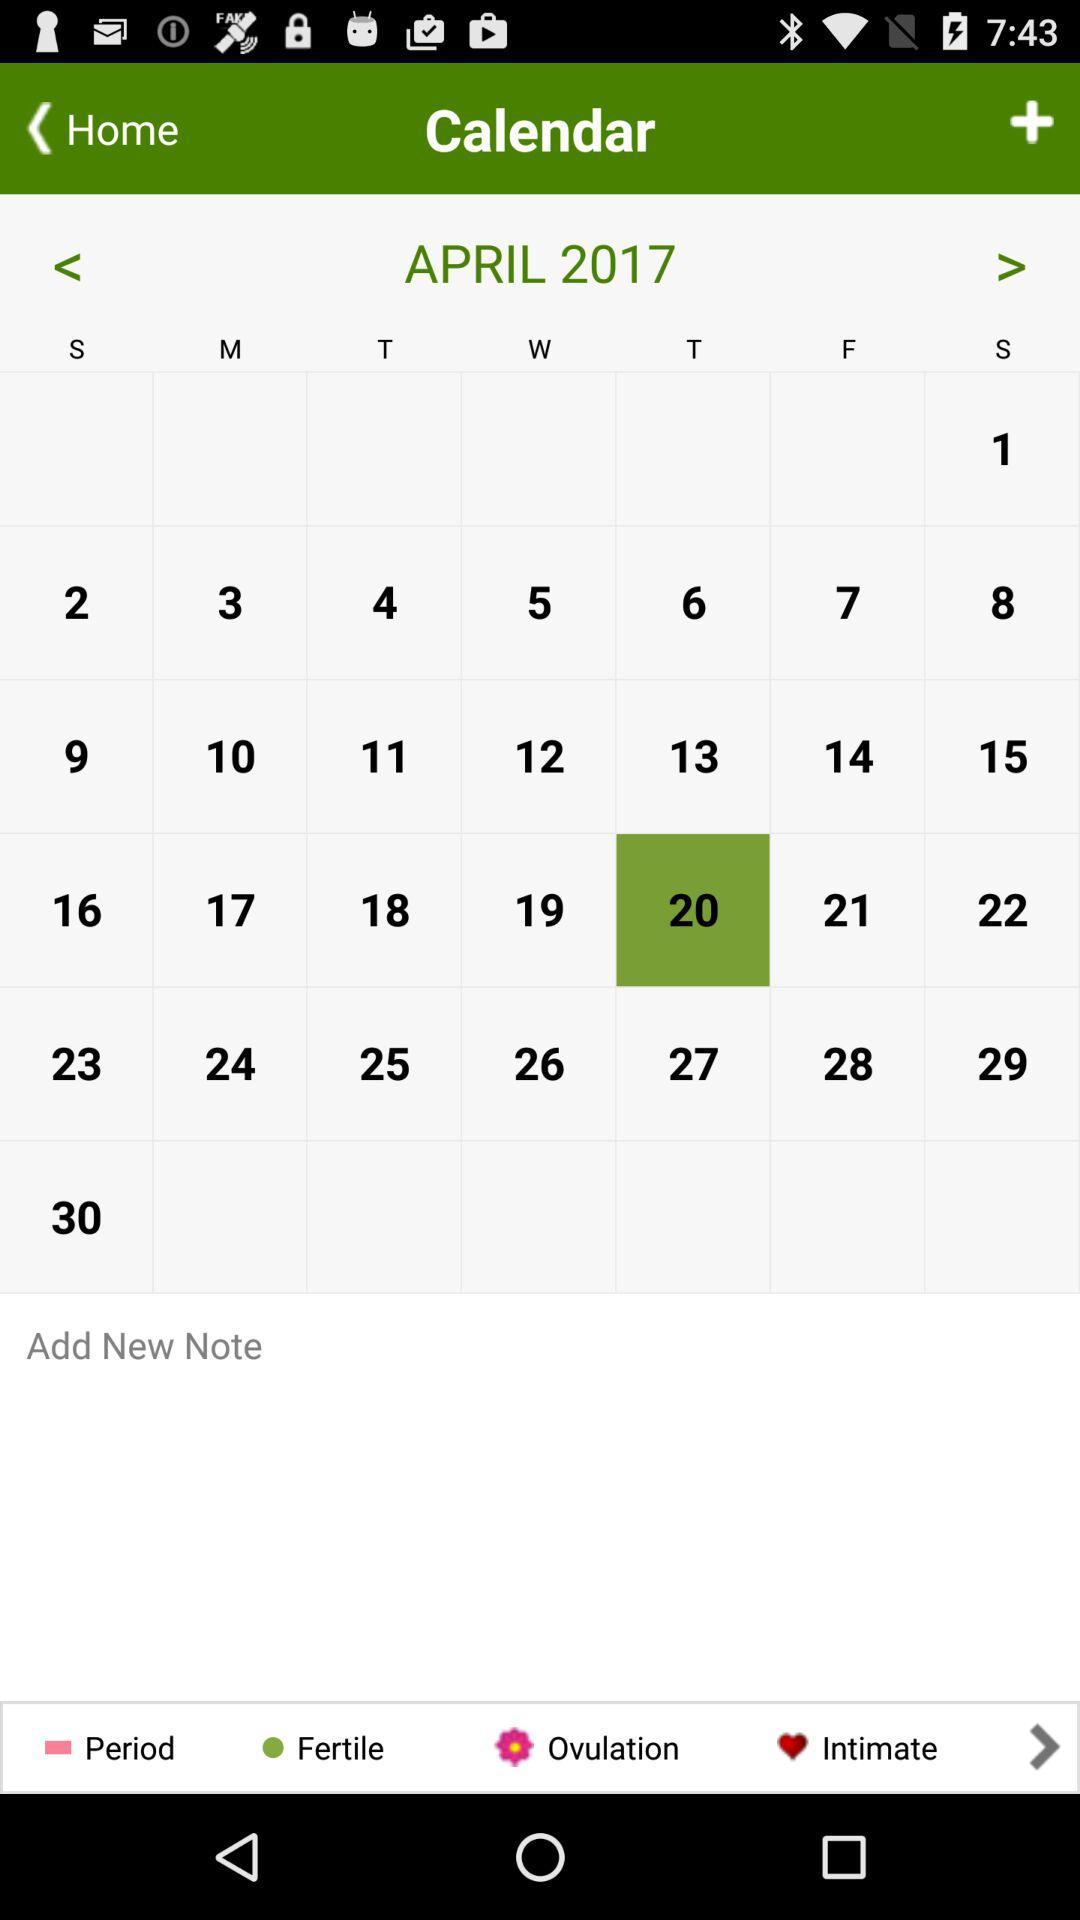Which date is selected on the screen? The selected date on the screen is Thursday, April 20, 2017. 